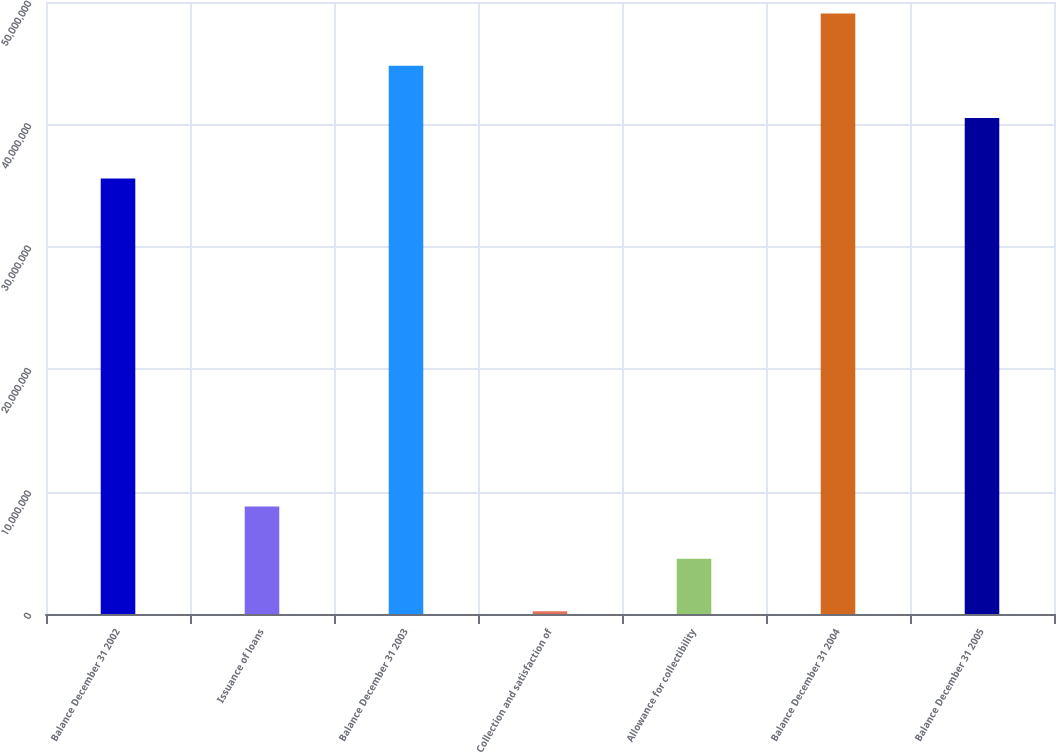<chart> <loc_0><loc_0><loc_500><loc_500><bar_chart><fcel>Balance December 31 2002<fcel>Issuance of loans<fcel>Balance December 31 2003<fcel>Collection and satisfaction of<fcel>Allowance for collectibility<fcel>Balance December 31 2004<fcel>Balance December 31 2005<nl><fcel>3.5577e+07<fcel>8.7896e+06<fcel>4.47996e+07<fcel>223000<fcel>4.521e+06<fcel>4.90682e+07<fcel>4.0531e+07<nl></chart> 